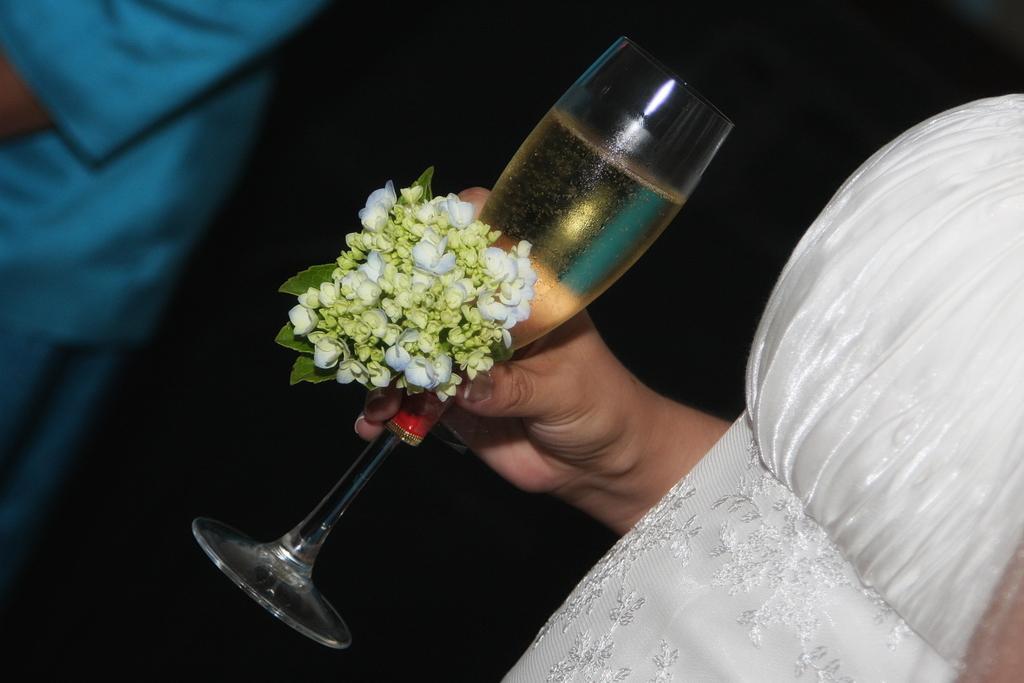Can you describe this image briefly? In this image there is a woman holding the glass of wine and flowers. In front of her there is another person. 